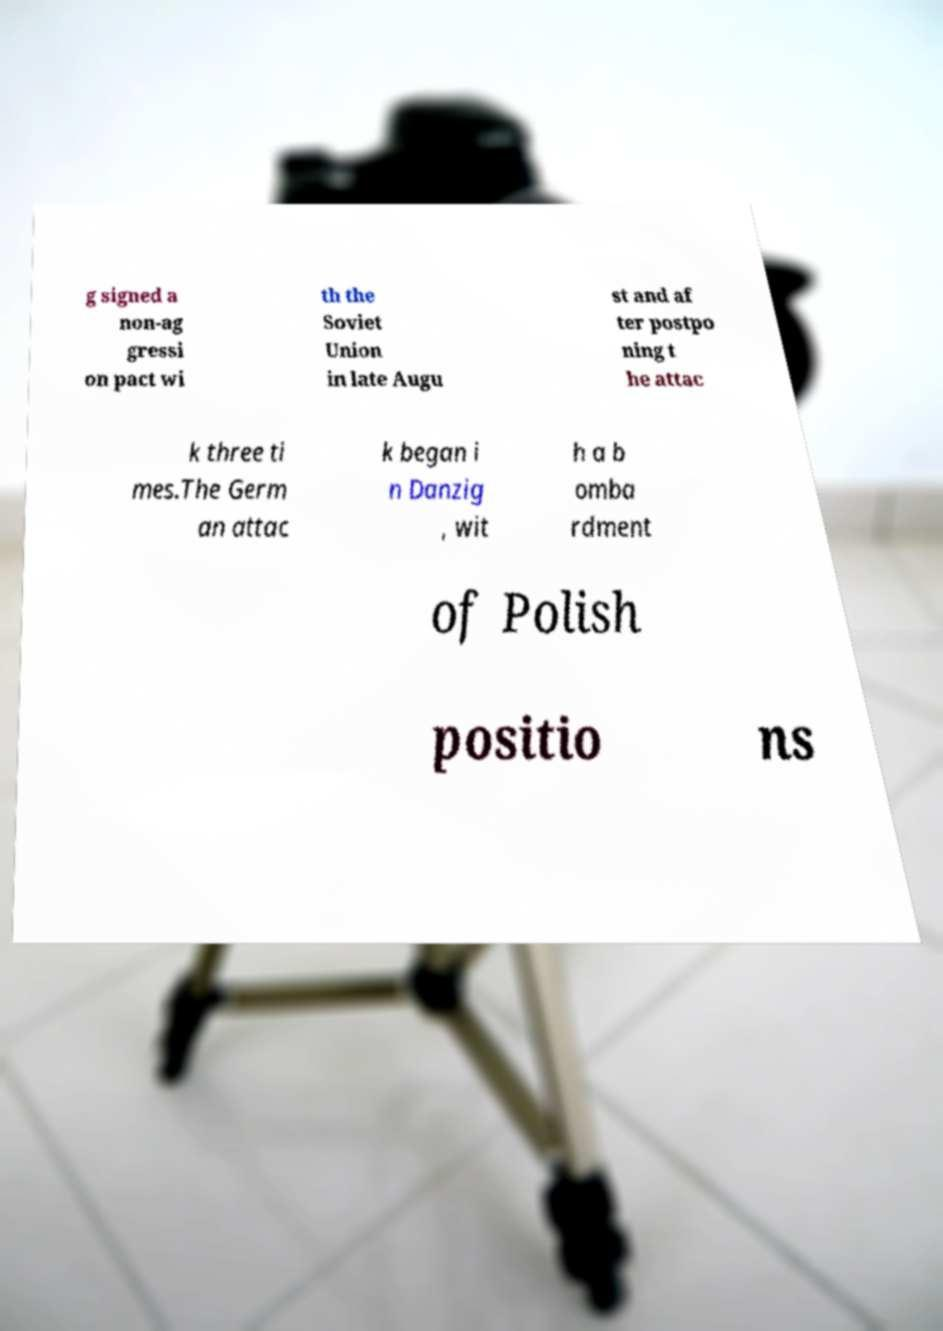Please identify and transcribe the text found in this image. g signed a non-ag gressi on pact wi th the Soviet Union in late Augu st and af ter postpo ning t he attac k three ti mes.The Germ an attac k began i n Danzig , wit h a b omba rdment of Polish positio ns 